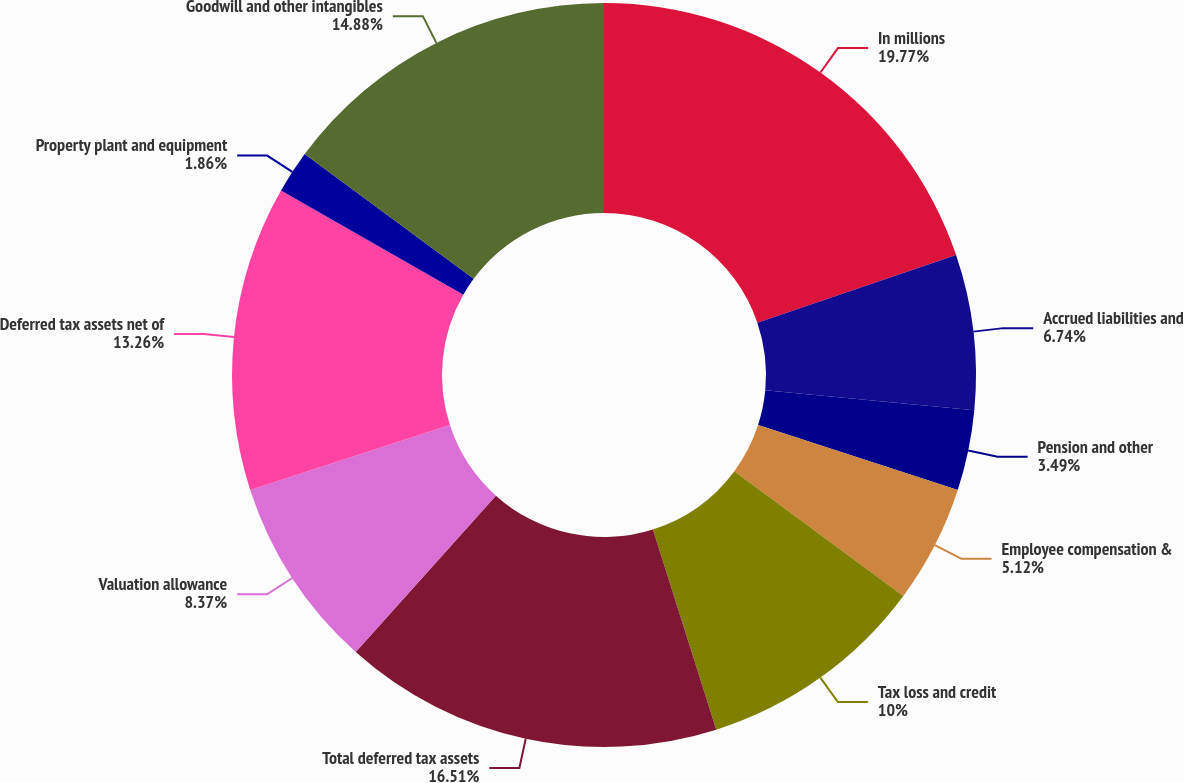Convert chart to OTSL. <chart><loc_0><loc_0><loc_500><loc_500><pie_chart><fcel>In millions<fcel>Accrued liabilities and<fcel>Pension and other<fcel>Employee compensation &<fcel>Tax loss and credit<fcel>Total deferred tax assets<fcel>Valuation allowance<fcel>Deferred tax assets net of<fcel>Property plant and equipment<fcel>Goodwill and other intangibles<nl><fcel>19.77%<fcel>6.74%<fcel>3.49%<fcel>5.12%<fcel>10.0%<fcel>16.51%<fcel>8.37%<fcel>13.26%<fcel>1.86%<fcel>14.88%<nl></chart> 